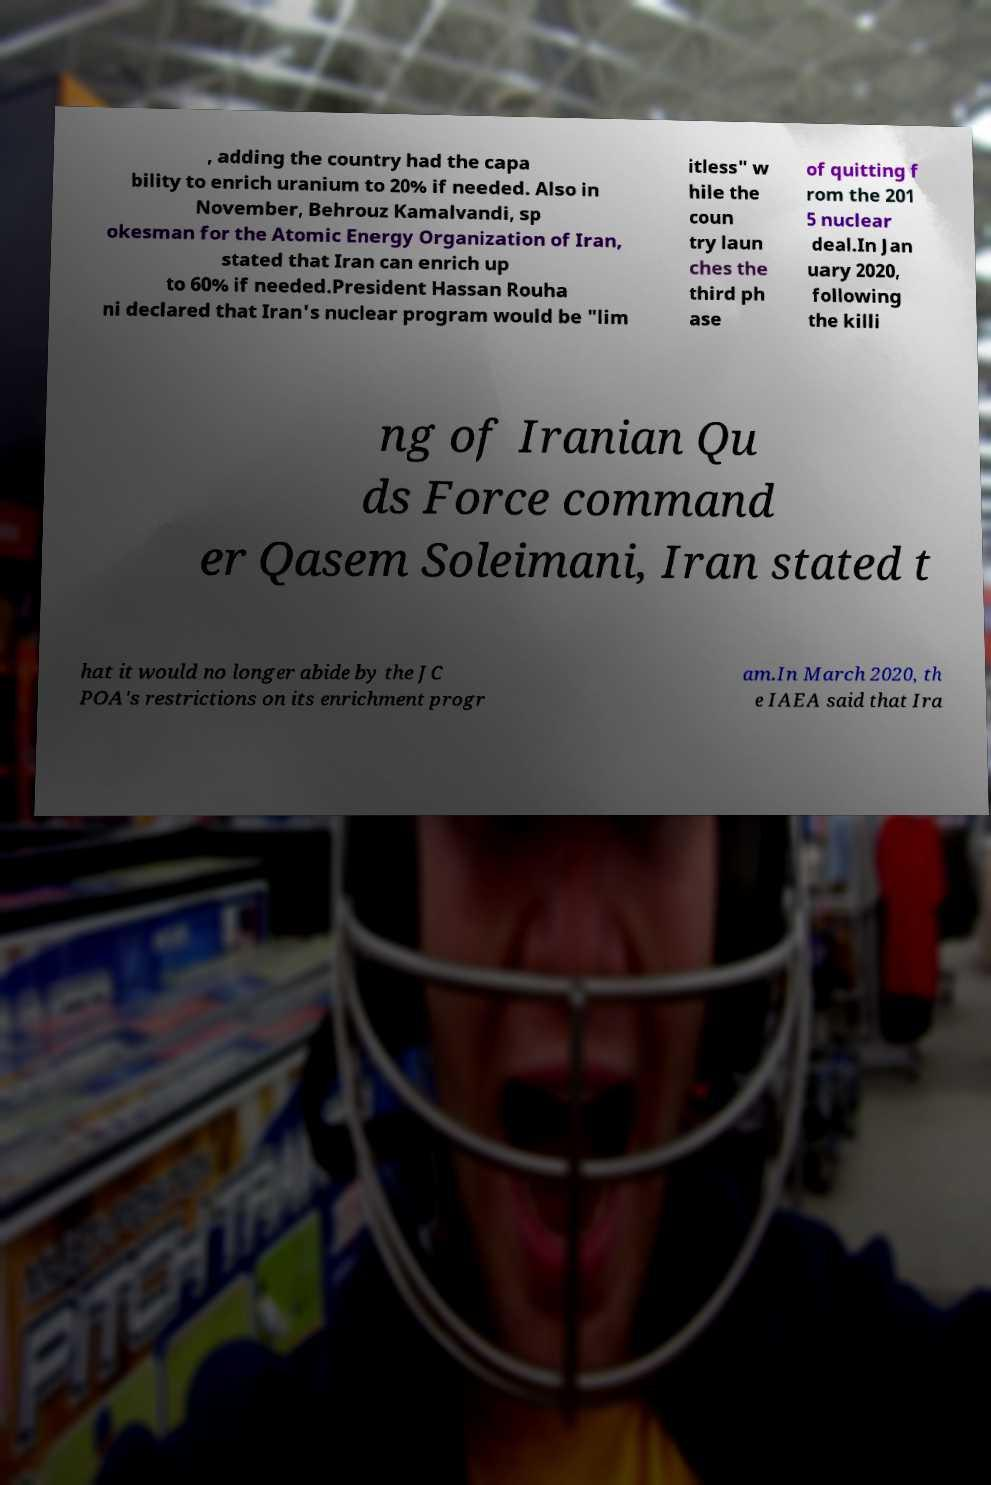Please read and relay the text visible in this image. What does it say? , adding the country had the capa bility to enrich uranium to 20% if needed. Also in November, Behrouz Kamalvandi, sp okesman for the Atomic Energy Organization of Iran, stated that Iran can enrich up to 60% if needed.President Hassan Rouha ni declared that Iran's nuclear program would be "lim itless" w hile the coun try laun ches the third ph ase of quitting f rom the 201 5 nuclear deal.In Jan uary 2020, following the killi ng of Iranian Qu ds Force command er Qasem Soleimani, Iran stated t hat it would no longer abide by the JC POA's restrictions on its enrichment progr am.In March 2020, th e IAEA said that Ira 